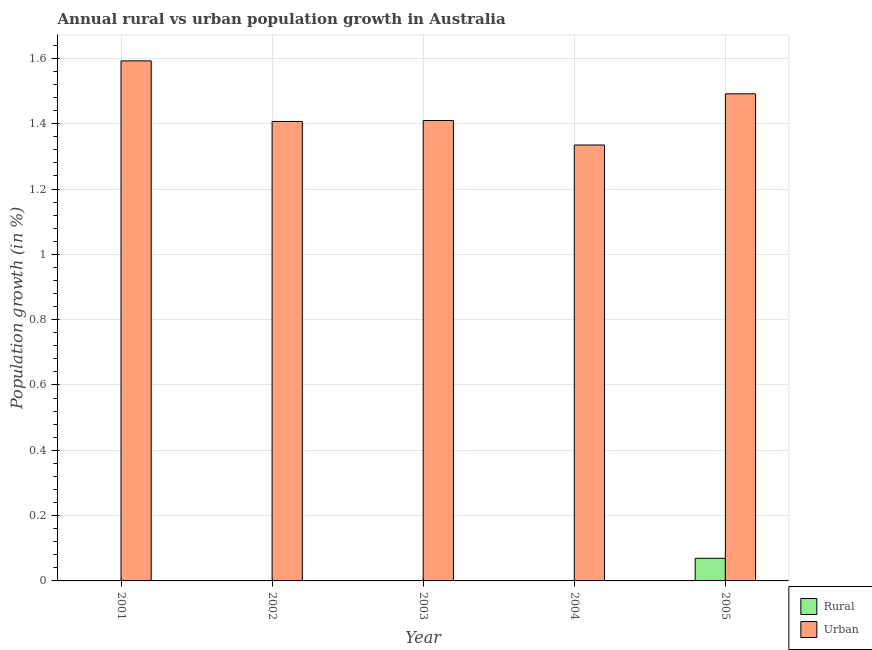How many different coloured bars are there?
Make the answer very short. 2. Are the number of bars per tick equal to the number of legend labels?
Your answer should be very brief. No. How many bars are there on the 2nd tick from the left?
Your answer should be compact. 1. What is the label of the 5th group of bars from the left?
Offer a very short reply. 2005. What is the urban population growth in 2004?
Keep it short and to the point. 1.33. Across all years, what is the maximum urban population growth?
Offer a very short reply. 1.59. Across all years, what is the minimum urban population growth?
Offer a terse response. 1.33. In which year was the urban population growth maximum?
Keep it short and to the point. 2001. What is the total urban population growth in the graph?
Provide a succinct answer. 7.24. What is the difference between the urban population growth in 2002 and that in 2005?
Offer a very short reply. -0.08. What is the difference between the rural population growth in 2005 and the urban population growth in 2004?
Your response must be concise. 0.07. What is the average urban population growth per year?
Your answer should be compact. 1.45. In the year 2002, what is the difference between the urban population growth and rural population growth?
Your response must be concise. 0. In how many years, is the urban population growth greater than 0.92 %?
Provide a short and direct response. 5. What is the ratio of the urban population growth in 2003 to that in 2004?
Keep it short and to the point. 1.06. Is the difference between the urban population growth in 2002 and 2005 greater than the difference between the rural population growth in 2002 and 2005?
Ensure brevity in your answer.  No. What is the difference between the highest and the second highest urban population growth?
Keep it short and to the point. 0.1. What is the difference between the highest and the lowest urban population growth?
Provide a short and direct response. 0.26. How many years are there in the graph?
Your response must be concise. 5. What is the difference between two consecutive major ticks on the Y-axis?
Provide a succinct answer. 0.2. Does the graph contain grids?
Provide a succinct answer. Yes. Where does the legend appear in the graph?
Offer a very short reply. Bottom right. How many legend labels are there?
Make the answer very short. 2. How are the legend labels stacked?
Make the answer very short. Vertical. What is the title of the graph?
Keep it short and to the point. Annual rural vs urban population growth in Australia. What is the label or title of the Y-axis?
Make the answer very short. Population growth (in %). What is the Population growth (in %) in Rural in 2001?
Offer a very short reply. 0. What is the Population growth (in %) in Urban  in 2001?
Keep it short and to the point. 1.59. What is the Population growth (in %) of Urban  in 2002?
Offer a very short reply. 1.41. What is the Population growth (in %) in Rural in 2003?
Provide a short and direct response. 0. What is the Population growth (in %) in Urban  in 2003?
Your answer should be compact. 1.41. What is the Population growth (in %) of Urban  in 2004?
Give a very brief answer. 1.33. What is the Population growth (in %) of Rural in 2005?
Make the answer very short. 0.07. What is the Population growth (in %) in Urban  in 2005?
Ensure brevity in your answer.  1.49. Across all years, what is the maximum Population growth (in %) in Rural?
Your answer should be compact. 0.07. Across all years, what is the maximum Population growth (in %) in Urban ?
Provide a succinct answer. 1.59. Across all years, what is the minimum Population growth (in %) of Urban ?
Offer a very short reply. 1.33. What is the total Population growth (in %) of Rural in the graph?
Your answer should be very brief. 0.07. What is the total Population growth (in %) in Urban  in the graph?
Your answer should be very brief. 7.24. What is the difference between the Population growth (in %) in Urban  in 2001 and that in 2002?
Your answer should be compact. 0.19. What is the difference between the Population growth (in %) of Urban  in 2001 and that in 2003?
Provide a succinct answer. 0.18. What is the difference between the Population growth (in %) of Urban  in 2001 and that in 2004?
Ensure brevity in your answer.  0.26. What is the difference between the Population growth (in %) of Urban  in 2001 and that in 2005?
Keep it short and to the point. 0.1. What is the difference between the Population growth (in %) in Urban  in 2002 and that in 2003?
Give a very brief answer. -0. What is the difference between the Population growth (in %) in Urban  in 2002 and that in 2004?
Your response must be concise. 0.07. What is the difference between the Population growth (in %) of Urban  in 2002 and that in 2005?
Offer a very short reply. -0.08. What is the difference between the Population growth (in %) in Urban  in 2003 and that in 2004?
Make the answer very short. 0.07. What is the difference between the Population growth (in %) in Urban  in 2003 and that in 2005?
Offer a very short reply. -0.08. What is the difference between the Population growth (in %) of Urban  in 2004 and that in 2005?
Offer a terse response. -0.16. What is the average Population growth (in %) of Rural per year?
Offer a very short reply. 0.01. What is the average Population growth (in %) of Urban  per year?
Ensure brevity in your answer.  1.45. In the year 2005, what is the difference between the Population growth (in %) of Rural and Population growth (in %) of Urban ?
Ensure brevity in your answer.  -1.42. What is the ratio of the Population growth (in %) of Urban  in 2001 to that in 2002?
Keep it short and to the point. 1.13. What is the ratio of the Population growth (in %) of Urban  in 2001 to that in 2003?
Offer a very short reply. 1.13. What is the ratio of the Population growth (in %) of Urban  in 2001 to that in 2004?
Offer a terse response. 1.19. What is the ratio of the Population growth (in %) of Urban  in 2001 to that in 2005?
Offer a very short reply. 1.07. What is the ratio of the Population growth (in %) in Urban  in 2002 to that in 2003?
Provide a succinct answer. 1. What is the ratio of the Population growth (in %) of Urban  in 2002 to that in 2004?
Your response must be concise. 1.05. What is the ratio of the Population growth (in %) of Urban  in 2002 to that in 2005?
Your answer should be compact. 0.94. What is the ratio of the Population growth (in %) in Urban  in 2003 to that in 2004?
Provide a short and direct response. 1.06. What is the ratio of the Population growth (in %) of Urban  in 2003 to that in 2005?
Offer a terse response. 0.95. What is the ratio of the Population growth (in %) in Urban  in 2004 to that in 2005?
Provide a succinct answer. 0.89. What is the difference between the highest and the second highest Population growth (in %) of Urban ?
Offer a very short reply. 0.1. What is the difference between the highest and the lowest Population growth (in %) in Rural?
Offer a terse response. 0.07. What is the difference between the highest and the lowest Population growth (in %) in Urban ?
Provide a short and direct response. 0.26. 